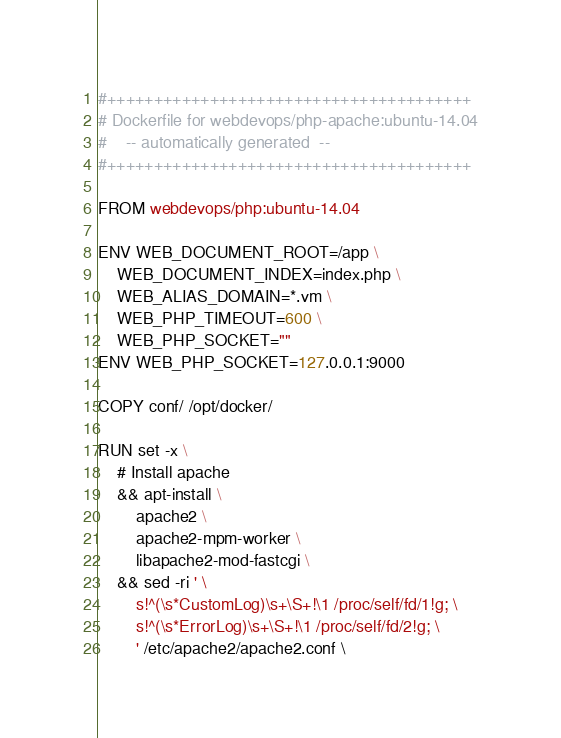Convert code to text. <code><loc_0><loc_0><loc_500><loc_500><_Dockerfile_>#+++++++++++++++++++++++++++++++++++++++
# Dockerfile for webdevops/php-apache:ubuntu-14.04
#    -- automatically generated  --
#+++++++++++++++++++++++++++++++++++++++

FROM webdevops/php:ubuntu-14.04

ENV WEB_DOCUMENT_ROOT=/app \
    WEB_DOCUMENT_INDEX=index.php \
    WEB_ALIAS_DOMAIN=*.vm \
    WEB_PHP_TIMEOUT=600 \
    WEB_PHP_SOCKET=""
ENV WEB_PHP_SOCKET=127.0.0.1:9000

COPY conf/ /opt/docker/

RUN set -x \
    # Install apache
    && apt-install \
        apache2 \
        apache2-mpm-worker \
        libapache2-mod-fastcgi \
	&& sed -ri ' \
		s!^(\s*CustomLog)\s+\S+!\1 /proc/self/fd/1!g; \
		s!^(\s*ErrorLog)\s+\S+!\1 /proc/self/fd/2!g; \
		' /etc/apache2/apache2.conf \</code> 